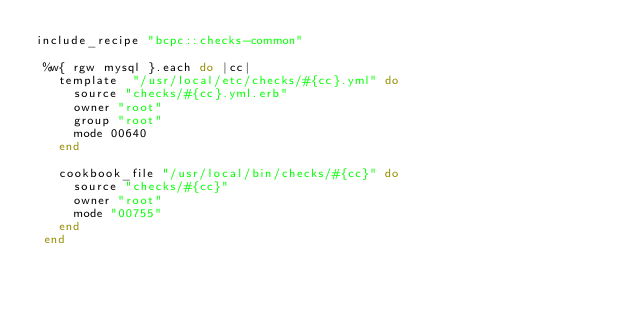Convert code to text. <code><loc_0><loc_0><loc_500><loc_500><_Ruby_>include_recipe "bcpc::checks-common"

 %w{ rgw mysql }.each do |cc|
   template  "/usr/local/etc/checks/#{cc}.yml" do
     source "checks/#{cc}.yml.erb"
     owner "root"
     group "root"
     mode 00640
   end

   cookbook_file "/usr/local/bin/checks/#{cc}" do
     source "checks/#{cc}"
     owner "root"
     mode "00755"
   end
 end

</code> 